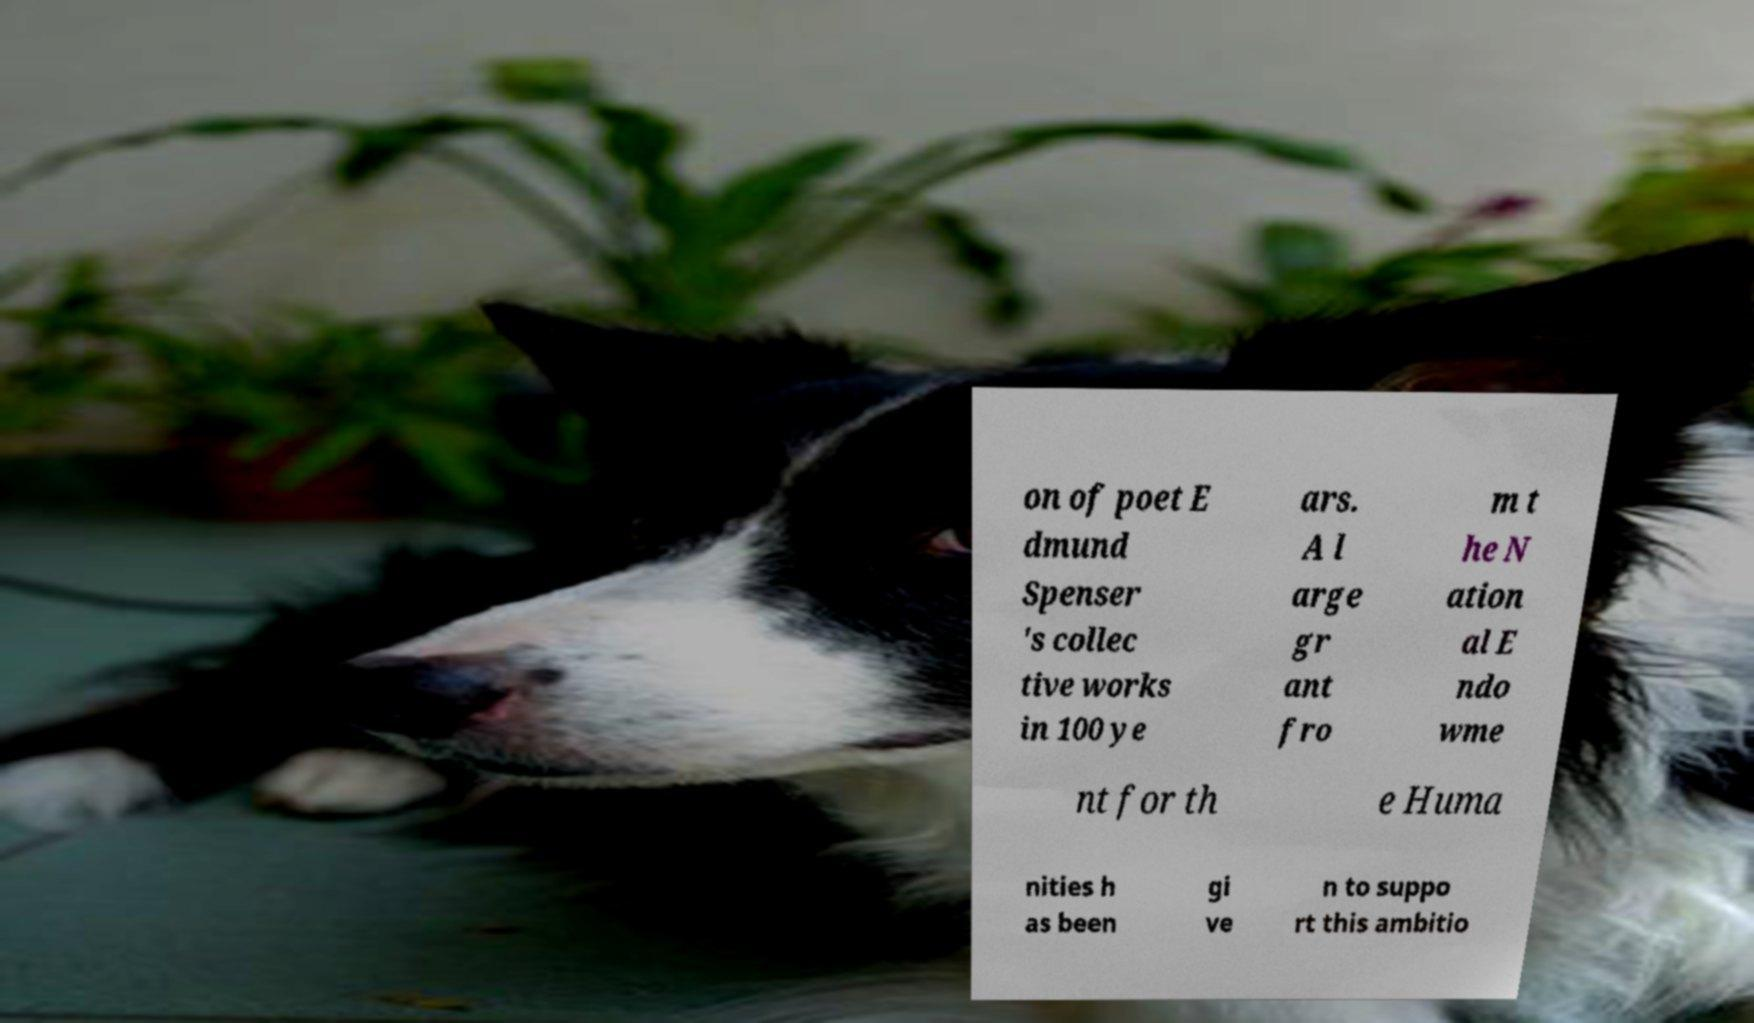Can you read and provide the text displayed in the image?This photo seems to have some interesting text. Can you extract and type it out for me? on of poet E dmund Spenser 's collec tive works in 100 ye ars. A l arge gr ant fro m t he N ation al E ndo wme nt for th e Huma nities h as been gi ve n to suppo rt this ambitio 